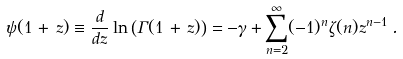<formula> <loc_0><loc_0><loc_500><loc_500>\psi ( 1 \, + \, z ) \equiv \frac { d } { d z } \ln \left ( \Gamma ( 1 \, + \, z ) \right ) = - \gamma + \sum _ { n = 2 } ^ { \infty } ( - 1 ) ^ { n } \zeta ( n ) z ^ { n - 1 } \, .</formula> 